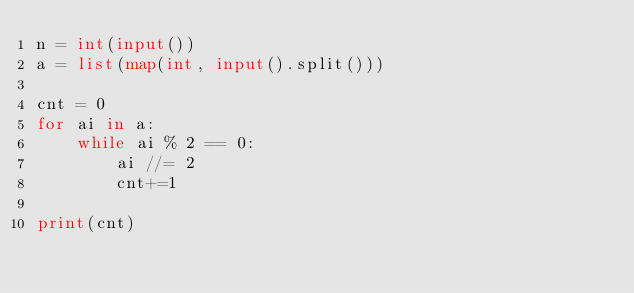Convert code to text. <code><loc_0><loc_0><loc_500><loc_500><_Python_>n = int(input())
a = list(map(int, input().split()))

cnt = 0
for ai in a:
    while ai % 2 == 0:
        ai //= 2
        cnt+=1
        
print(cnt)</code> 